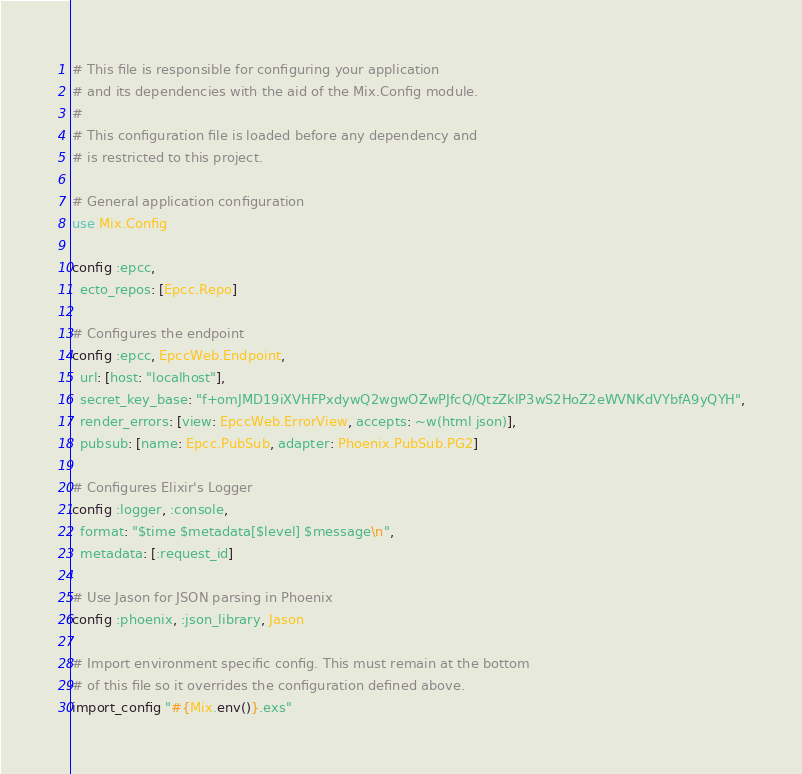<code> <loc_0><loc_0><loc_500><loc_500><_Elixir_># This file is responsible for configuring your application
# and its dependencies with the aid of the Mix.Config module.
#
# This configuration file is loaded before any dependency and
# is restricted to this project.

# General application configuration
use Mix.Config

config :epcc,
  ecto_repos: [Epcc.Repo]

# Configures the endpoint
config :epcc, EpccWeb.Endpoint,
  url: [host: "localhost"],
  secret_key_base: "f+omJMD19iXVHFPxdywQ2wgwOZwPJfcQ/QtzZklP3wS2HoZ2eWVNKdVYbfA9yQYH",
  render_errors: [view: EpccWeb.ErrorView, accepts: ~w(html json)],
  pubsub: [name: Epcc.PubSub, adapter: Phoenix.PubSub.PG2]

# Configures Elixir's Logger
config :logger, :console,
  format: "$time $metadata[$level] $message\n",
  metadata: [:request_id]

# Use Jason for JSON parsing in Phoenix
config :phoenix, :json_library, Jason

# Import environment specific config. This must remain at the bottom
# of this file so it overrides the configuration defined above.
import_config "#{Mix.env()}.exs"
</code> 